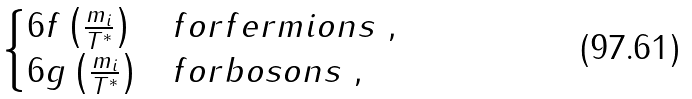<formula> <loc_0><loc_0><loc_500><loc_500>\begin{cases} 6 f \left ( \frac { m _ { i } } { T ^ { * } } \right ) & f o r f e r m i o n s \ , \\ 6 g \left ( \frac { m _ { i } } { T ^ { * } } \right ) & f o r b o s o n s \ , \end{cases}</formula> 